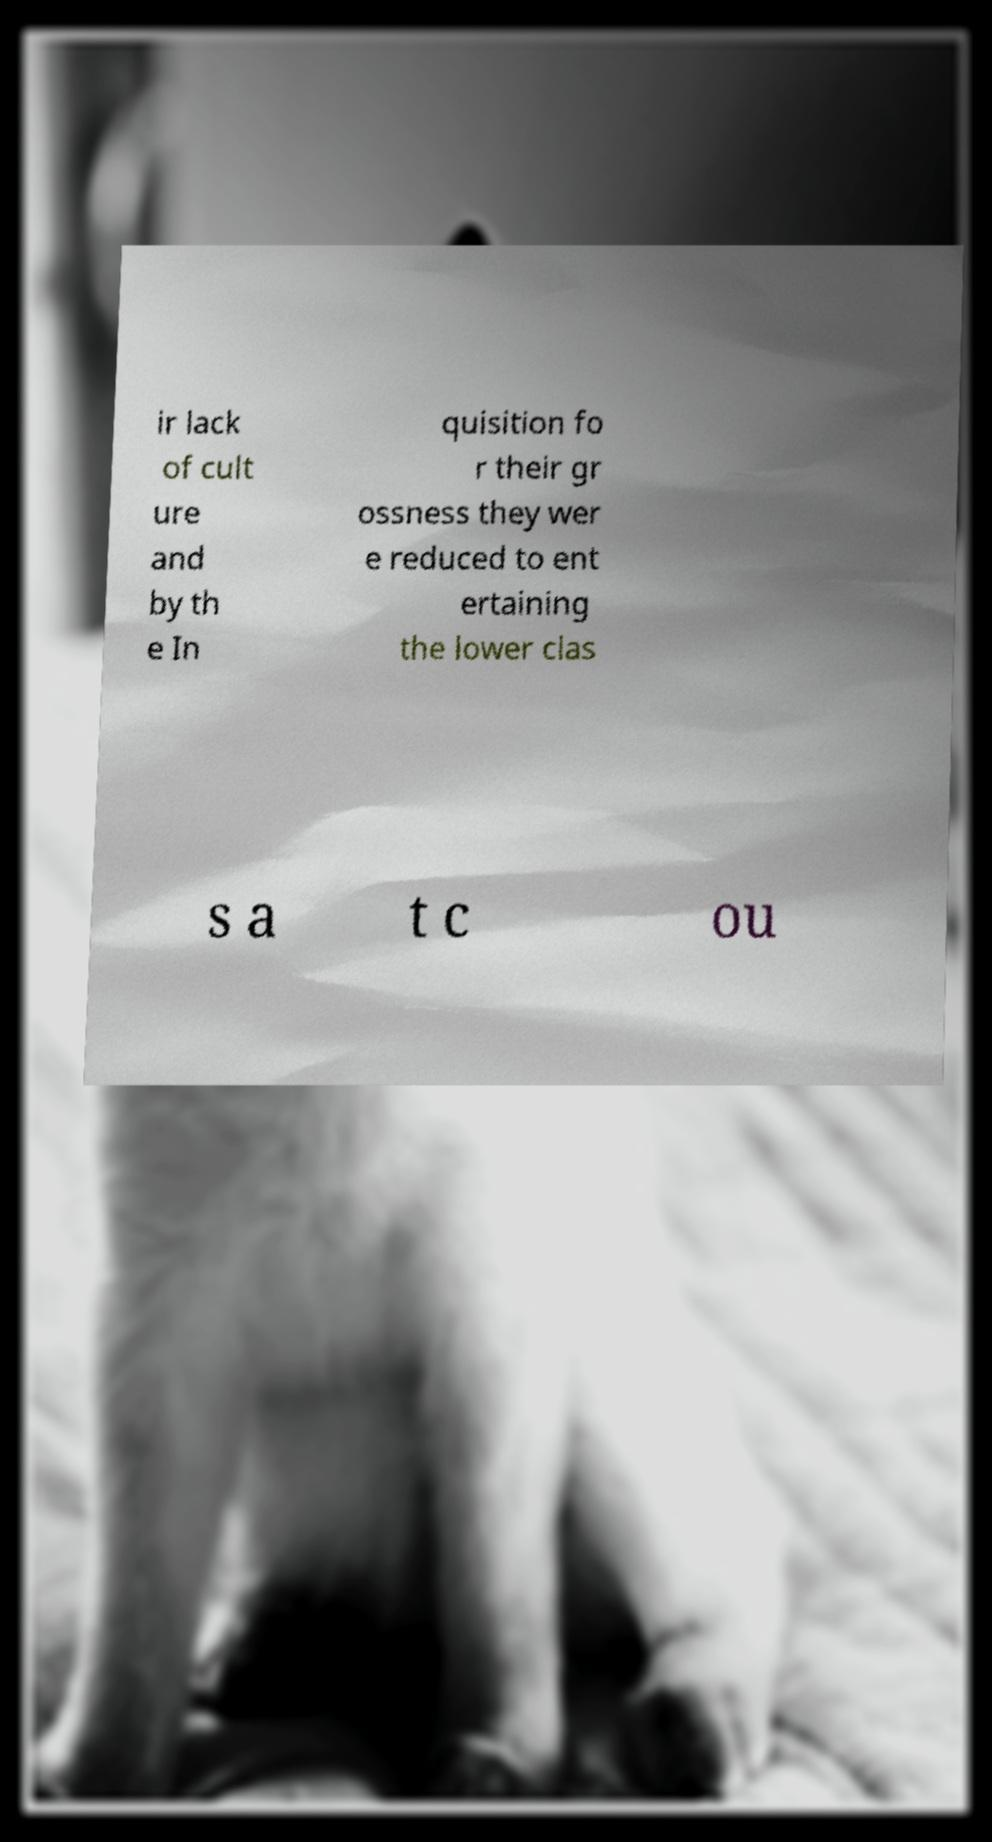Can you accurately transcribe the text from the provided image for me? ir lack of cult ure and by th e In quisition fo r their gr ossness they wer e reduced to ent ertaining the lower clas s a t c ou 